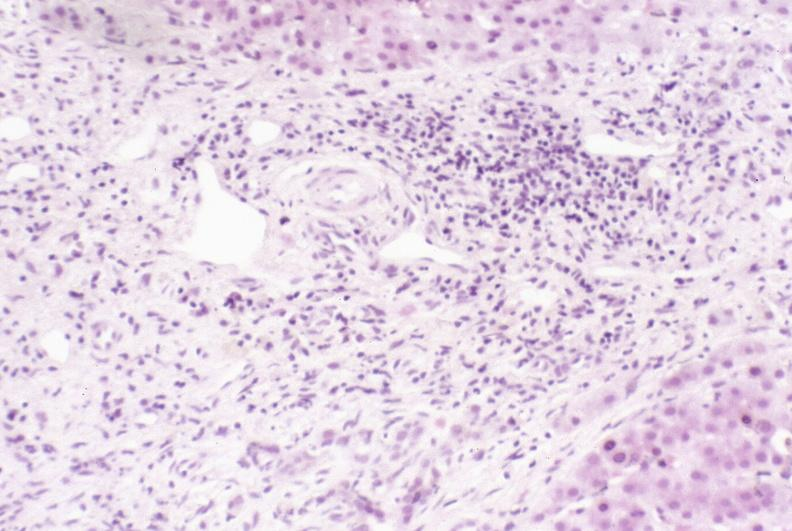does this image show primary sclerosing cholangitis?
Answer the question using a single word or phrase. Yes 